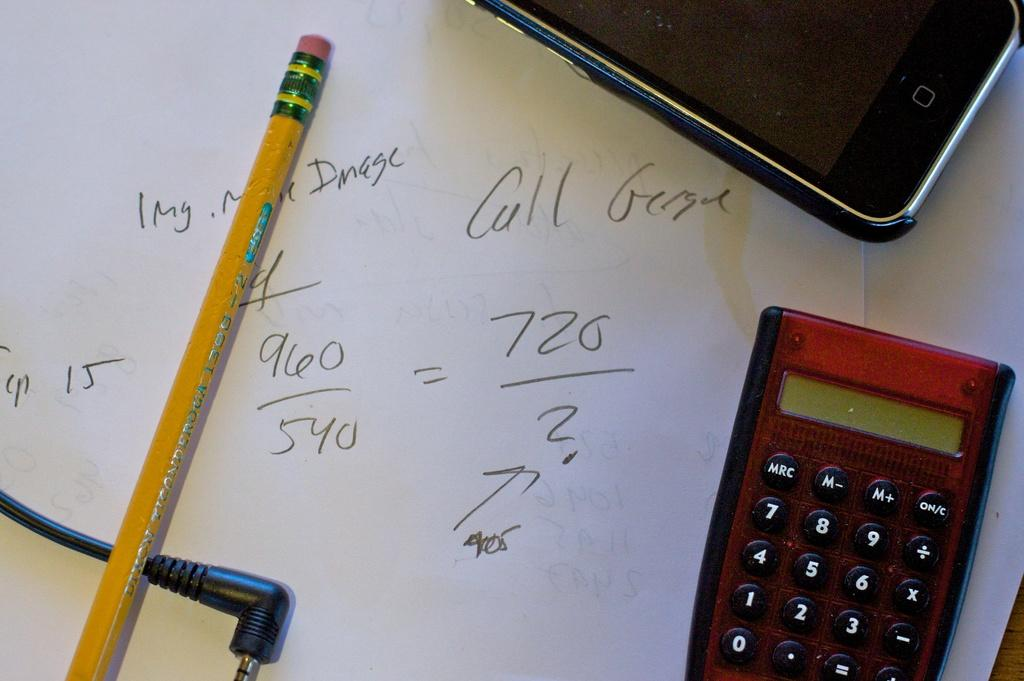<image>
Give a short and clear explanation of the subsequent image. notes on a paper reading call George and math equations 